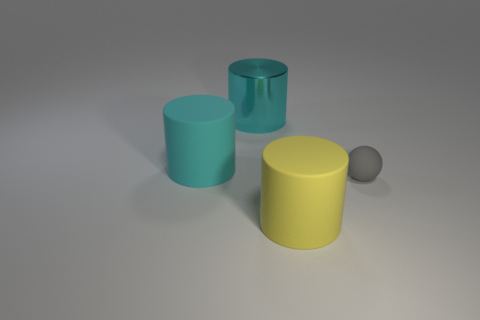How many yellow cylinders are to the right of the cylinder to the left of the cyan object behind the cyan rubber object?
Give a very brief answer. 1. Are there any yellow matte objects to the left of the big cyan matte object?
Give a very brief answer. No. Is there anything else of the same color as the sphere?
Give a very brief answer. No. How many cylinders are yellow rubber things or large metallic things?
Offer a very short reply. 2. How many big matte objects are behind the gray rubber sphere and in front of the small rubber sphere?
Ensure brevity in your answer.  0. Are there an equal number of yellow cylinders that are behind the gray object and cylinders to the right of the big cyan metal object?
Provide a succinct answer. No. Does the big matte thing on the right side of the large cyan metallic cylinder have the same shape as the tiny rubber object?
Keep it short and to the point. No. There is a matte thing that is to the right of the cylinder that is in front of the matte cylinder to the left of the big metal cylinder; what shape is it?
Provide a succinct answer. Sphere. What shape is the other object that is the same color as the large shiny object?
Your answer should be compact. Cylinder. What is the material of the big cylinder that is in front of the shiny thing and on the right side of the large cyan rubber object?
Make the answer very short. Rubber. 